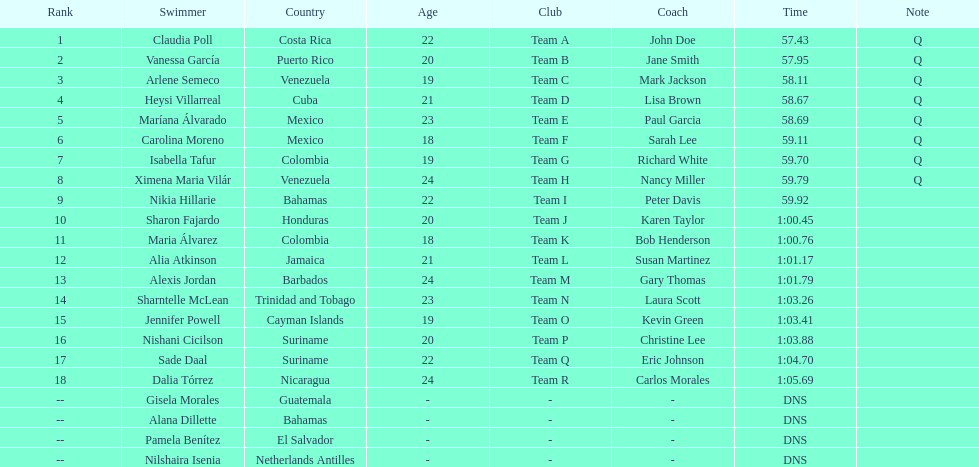What swimmer had the top or first rank? Claudia Poll. 